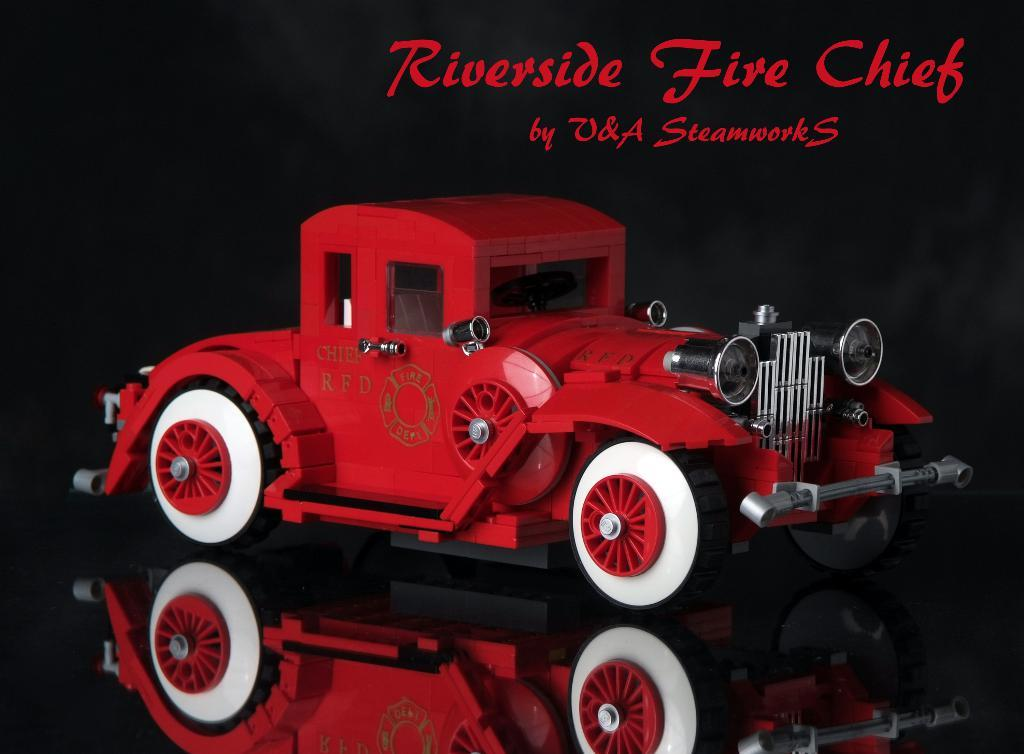What is the main object in the center of the image? There is a toy car in the center of the image. What else can be seen at the top of the image? There is text at the top of the image. How many boys are connected to the building in the image? There are no boys or buildings present in the image; it only features a toy car and text. 